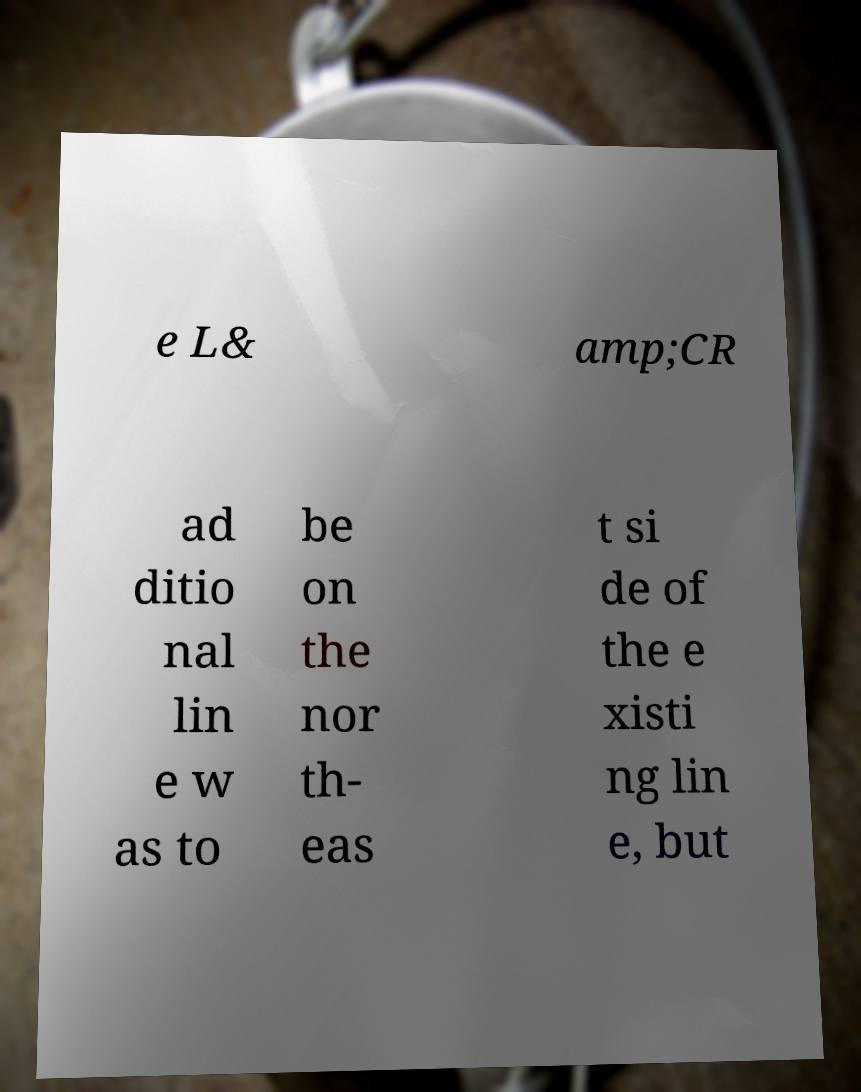There's text embedded in this image that I need extracted. Can you transcribe it verbatim? e L& amp;CR ad ditio nal lin e w as to be on the nor th- eas t si de of the e xisti ng lin e, but 